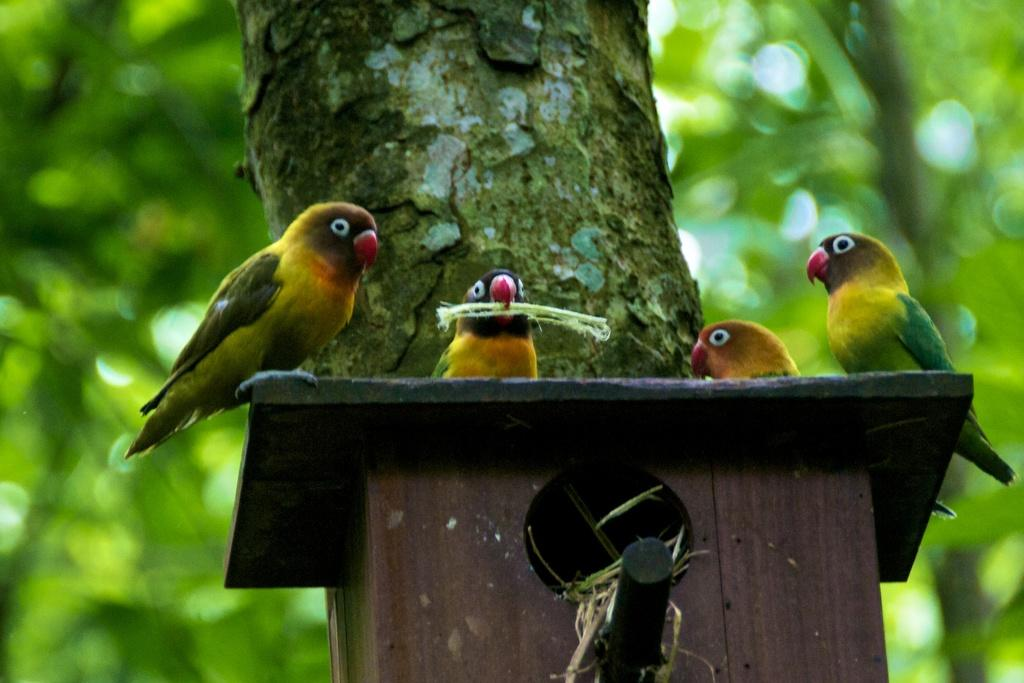How many parrots are in the image? There are four parrots in the foreground of the image. Where are the parrots located? The parrots are on a bird house. What can be seen behind the bird house? There is a tree trunk visible behind the bird house. What type of environment is depicted in the background of the image? Greenery is present in the background of the image. What type of soup is being served in the image? There is no soup present in the image; it features four parrots on a bird house with a tree trunk and greenery in the background. 